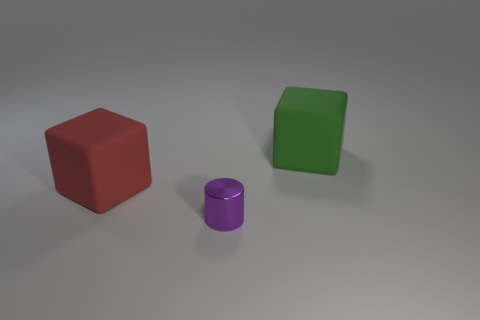Add 2 large cyan shiny cylinders. How many objects exist? 5 Subtract all blocks. How many objects are left? 1 Subtract 0 blue cylinders. How many objects are left? 3 Subtract all green rubber blocks. Subtract all small gray metal blocks. How many objects are left? 2 Add 2 green cubes. How many green cubes are left? 3 Add 2 purple cylinders. How many purple cylinders exist? 3 